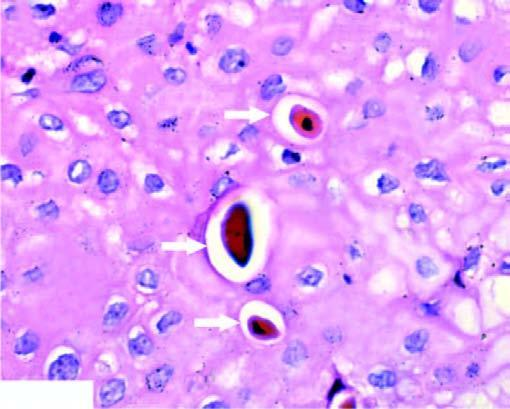where is the dead cell seen?
Answer the question using a single word or phrase. In singles 